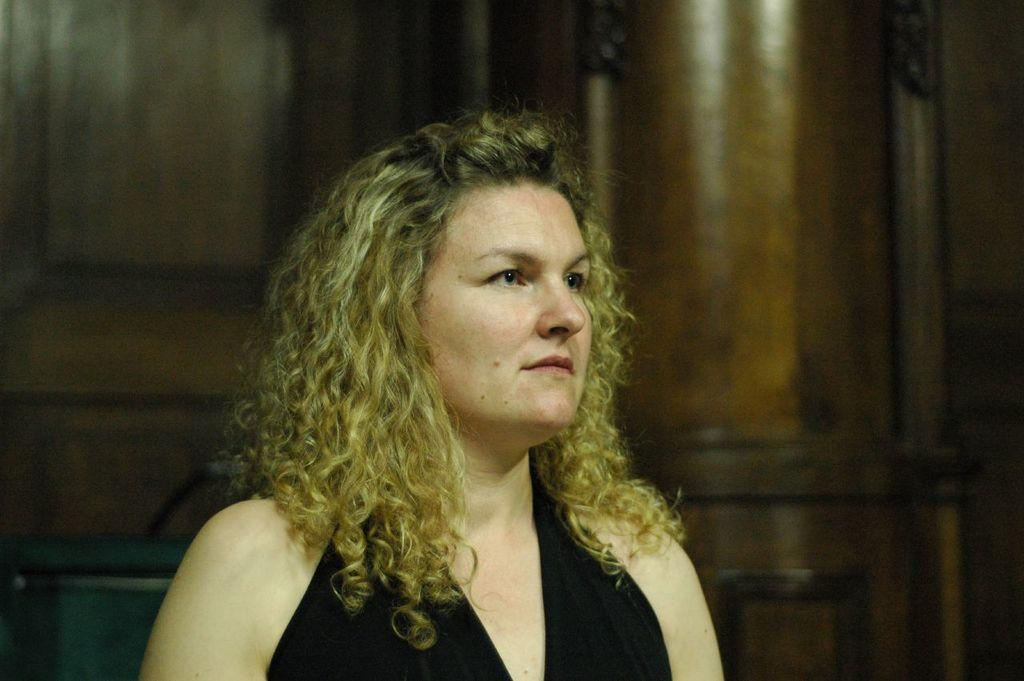Who is the main subject in the image? There is a woman in the center of the image. What is the woman wearing? The woman is wearing a black dress. What is the color of the woman's hair? The woman has golden hair. Can you describe the background of the image? The background of the image is blurry. What type of wristwatch is the woman wearing in the image? There is no mention of a wristwatch in the image, so it cannot be determined if the woman is wearing one. 